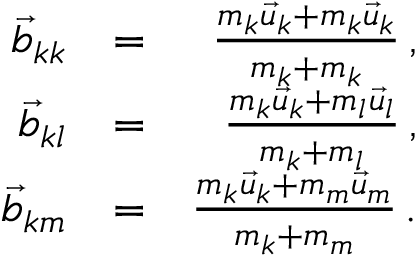<formula> <loc_0><loc_0><loc_500><loc_500>\begin{array} { r l r } { \vec { b } _ { k k } } & { = } & { \frac { m _ { k } \vec { u } _ { k } + m _ { k } \vec { u } _ { k } } { m _ { k } + m _ { k } } \, , } \\ { \vec { b } _ { k l } } & { = } & { \frac { m _ { k } \vec { u } _ { k } + m _ { l } \vec { u } _ { l } } { m _ { k } + m _ { l } } \, , } \\ { \vec { b } _ { k m } } & { = } & { \frac { m _ { k } \vec { u } _ { k } + m _ { m } \vec { u } _ { m } } { m _ { k } + m _ { m } } \, . } \end{array}</formula> 